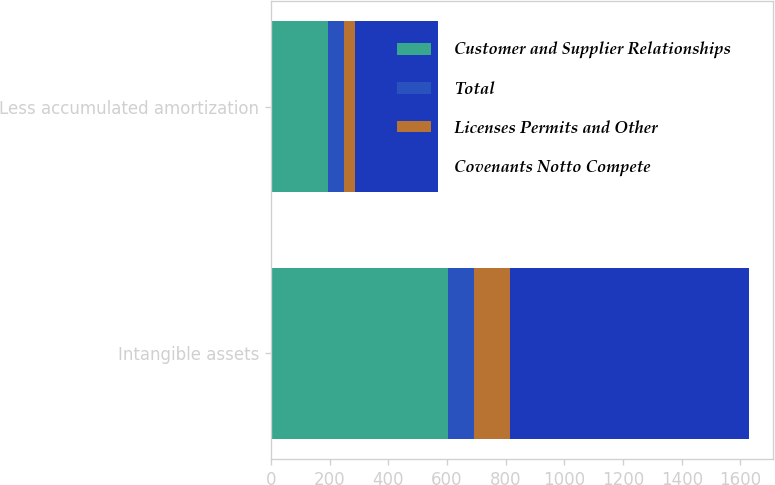Convert chart to OTSL. <chart><loc_0><loc_0><loc_500><loc_500><stacked_bar_chart><ecel><fcel>Intangible assets<fcel>Less accumulated amortization<nl><fcel>Customer and Supplier Relationships<fcel>604<fcel>193<nl><fcel>Total<fcel>87<fcel>57<nl><fcel>Licenses Permits and Other<fcel>123<fcel>35<nl><fcel>Covenants Notto Compete<fcel>814<fcel>285<nl></chart> 